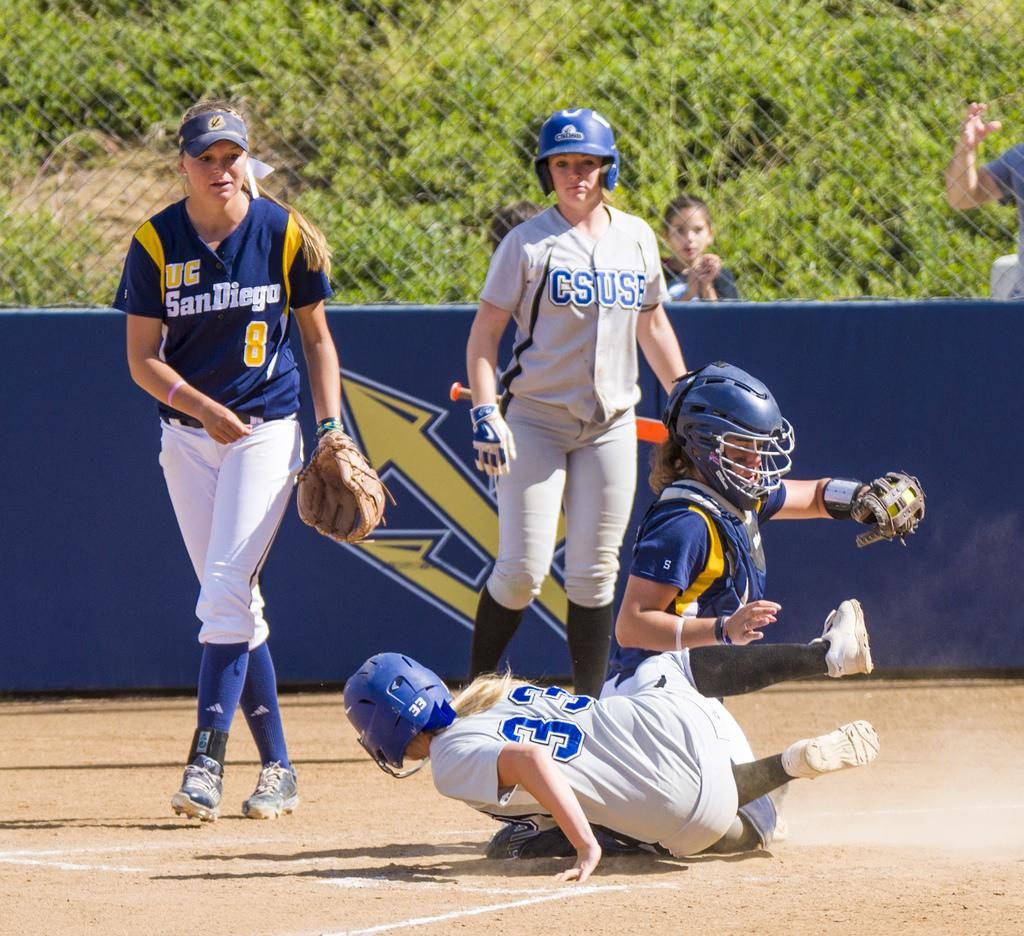<image>
Give a short and clear explanation of the subsequent image. Baseball player wearing the number 33 sliding into base. 